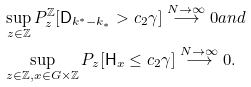Convert formula to latex. <formula><loc_0><loc_0><loc_500><loc_500>& \sup _ { z \in { \mathbb { Z } } } P ^ { \mathbb { Z } } _ { z } [ { \mathsf D } _ { k ^ { * } - k _ { * } } > c _ { 2 } \gamma ] \stackrel { N \to \infty } { \longrightarrow } 0 a n d \\ & \sup _ { z \in { \mathbb { Z } } , x \in G \times { \mathbb { Z } } } P _ { z } [ { \mathsf H } _ { x } \leq c _ { 2 } \gamma ] \stackrel { N \to \infty } { \longrightarrow } 0 .</formula> 